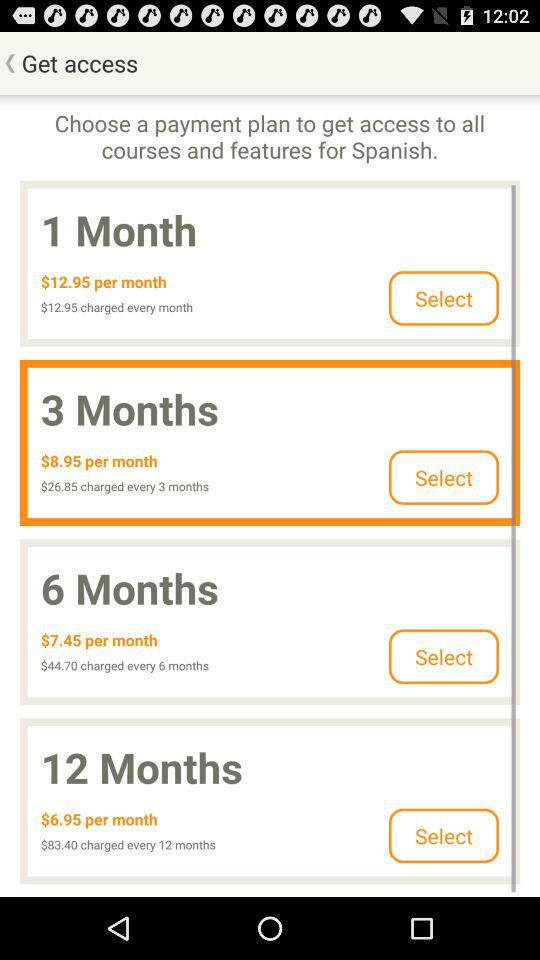What will be the charges for every six months? The charges for every six months will be $44.70. 